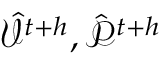Convert formula to latex. <formula><loc_0><loc_0><loc_500><loc_500>\hat { \mathcal { V } } ^ { t { + } h } , \hat { \mathcal { P } } ^ { t { + } h }</formula> 